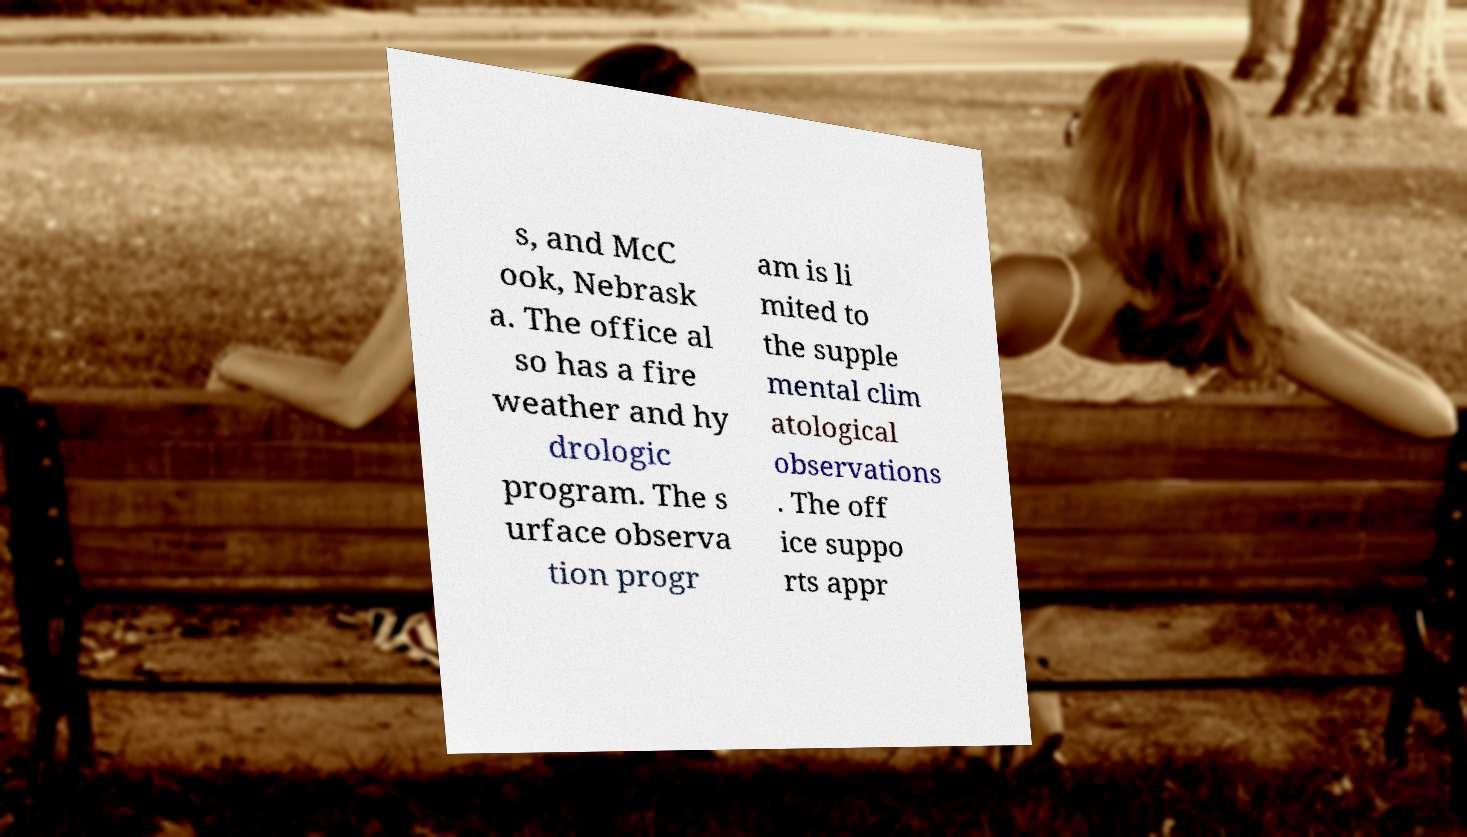For documentation purposes, I need the text within this image transcribed. Could you provide that? s, and McC ook, Nebrask a. The office al so has a fire weather and hy drologic program. The s urface observa tion progr am is li mited to the supple mental clim atological observations . The off ice suppo rts appr 